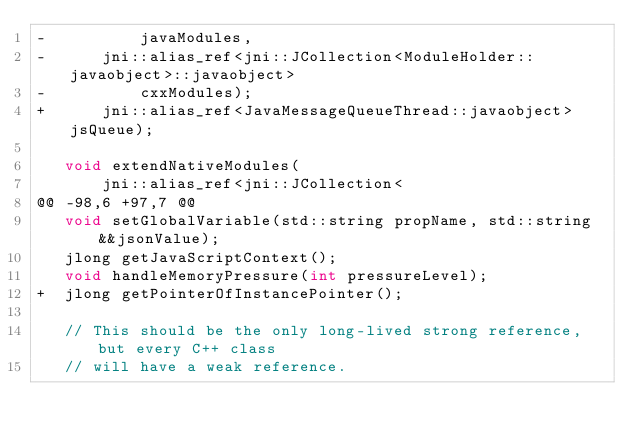Convert code to text. <code><loc_0><loc_0><loc_500><loc_500><_C_>-          javaModules,
-      jni::alias_ref<jni::JCollection<ModuleHolder::javaobject>::javaobject>
-          cxxModules);
+      jni::alias_ref<JavaMessageQueueThread::javaobject> jsQueue);
 
   void extendNativeModules(
       jni::alias_ref<jni::JCollection<
@@ -98,6 +97,7 @@
   void setGlobalVariable(std::string propName, std::string &&jsonValue);
   jlong getJavaScriptContext();
   void handleMemoryPressure(int pressureLevel);
+  jlong getPointerOfInstancePointer();
 
   // This should be the only long-lived strong reference, but every C++ class
   // will have a weak reference.
</code> 